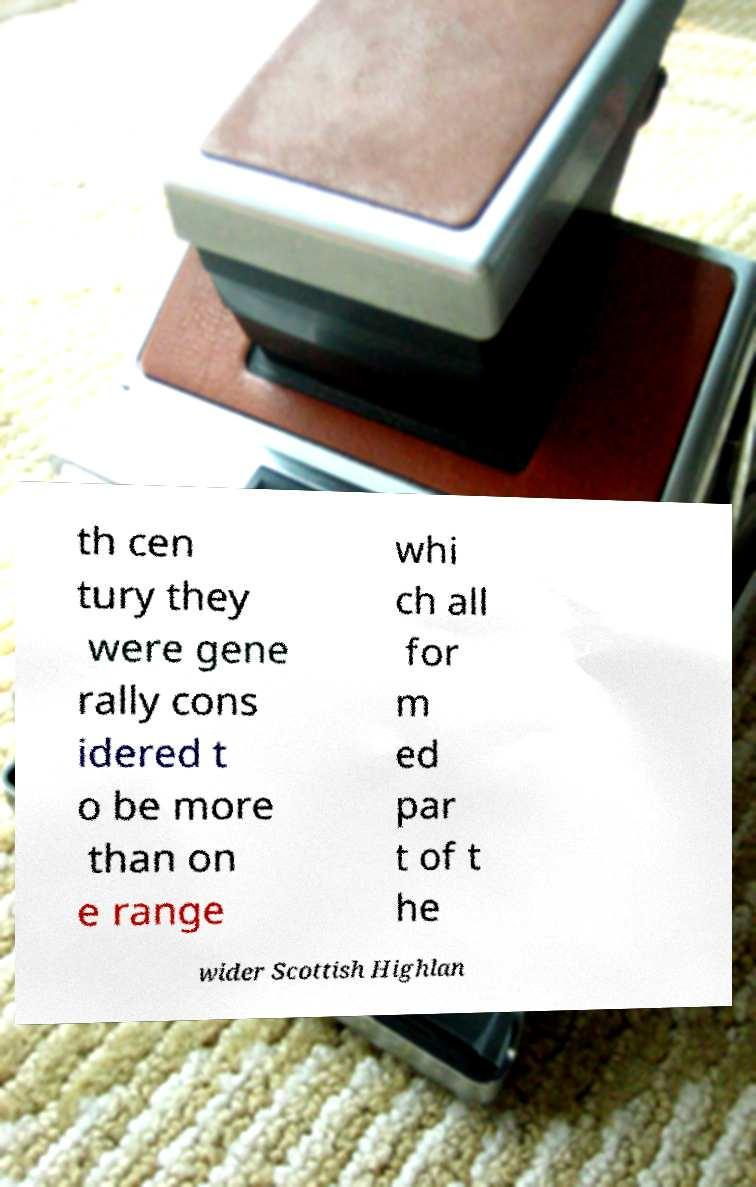I need the written content from this picture converted into text. Can you do that? th cen tury they were gene rally cons idered t o be more than on e range whi ch all for m ed par t of t he wider Scottish Highlan 